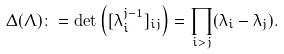Convert formula to latex. <formula><loc_0><loc_0><loc_500><loc_500>\Delta ( \Lambda ) \colon = \det \left ( [ \lambda _ { i } ^ { j - 1 } ] _ { i j } \right ) = \prod _ { i > j } ( \lambda _ { i } - \lambda _ { j } ) .</formula> 